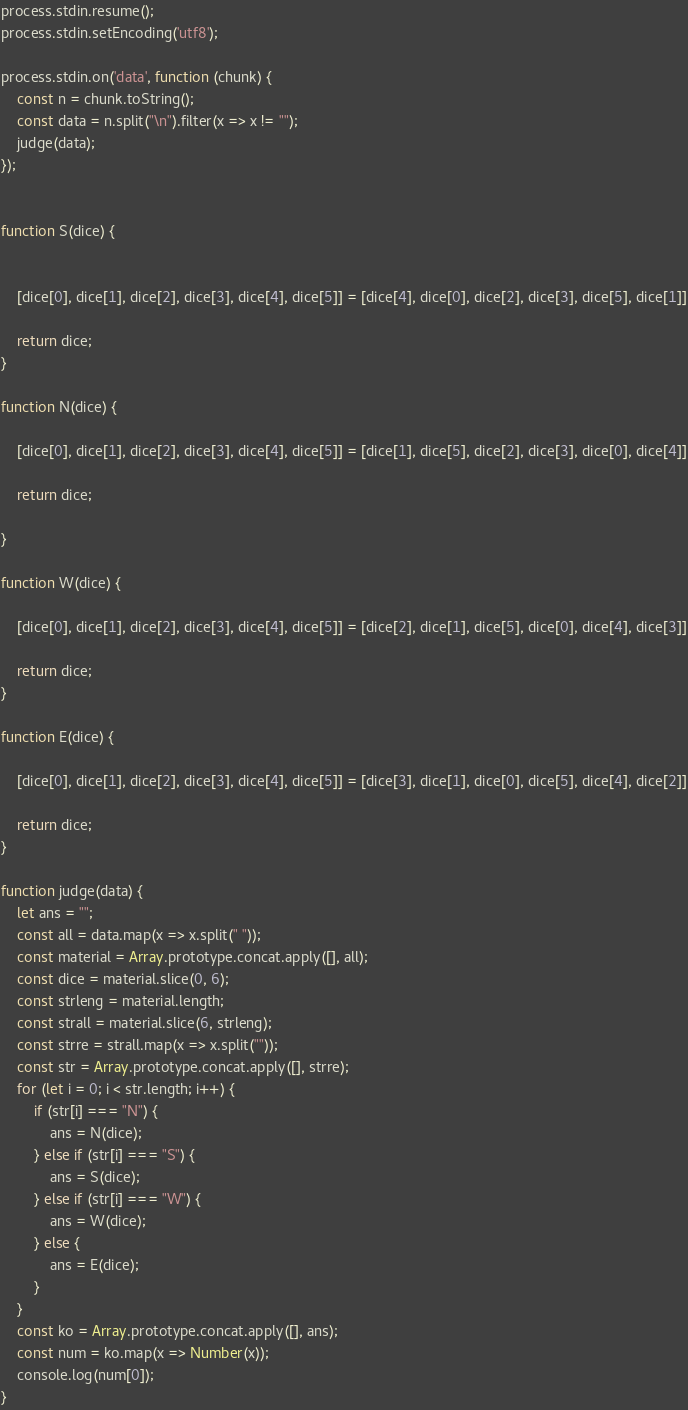<code> <loc_0><loc_0><loc_500><loc_500><_JavaScript_>process.stdin.resume();
process.stdin.setEncoding('utf8');

process.stdin.on('data', function (chunk) {
    const n = chunk.toString();
    const data = n.split("\n").filter(x => x != "");
    judge(data);
});


function S(dice) {


    [dice[0], dice[1], dice[2], dice[3], dice[4], dice[5]] = [dice[4], dice[0], dice[2], dice[3], dice[5], dice[1]]

    return dice;
}

function N(dice) {

    [dice[0], dice[1], dice[2], dice[3], dice[4], dice[5]] = [dice[1], dice[5], dice[2], dice[3], dice[0], dice[4]]

    return dice;

}

function W(dice) {

    [dice[0], dice[1], dice[2], dice[3], dice[4], dice[5]] = [dice[2], dice[1], dice[5], dice[0], dice[4], dice[3]]

    return dice;
}

function E(dice) {

    [dice[0], dice[1], dice[2], dice[3], dice[4], dice[5]] = [dice[3], dice[1], dice[0], dice[5], dice[4], dice[2]]

    return dice;
}

function judge(data) {
    let ans = "";
    const all = data.map(x => x.split(" "));
    const material = Array.prototype.concat.apply([], all);
    const dice = material.slice(0, 6);
    const strleng = material.length;
    const strall = material.slice(6, strleng);
    const strre = strall.map(x => x.split(""));
    const str = Array.prototype.concat.apply([], strre);
    for (let i = 0; i < str.length; i++) {
        if (str[i] === "N") {
            ans = N(dice);
        } else if (str[i] === "S") {
            ans = S(dice);
        } else if (str[i] === "W") {
            ans = W(dice);
        } else {
            ans = E(dice);
        }
    }
    const ko = Array.prototype.concat.apply([], ans);
    const num = ko.map(x => Number(x));
    console.log(num[0]);
}
</code> 